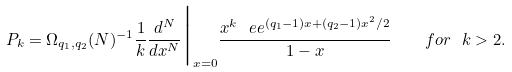<formula> <loc_0><loc_0><loc_500><loc_500>P _ { k } = \Omega _ { q _ { 1 } , q _ { 2 } } ( N ) ^ { - 1 } \frac { 1 } { k } \frac { d ^ { N } } { d x ^ { N } } \Big | _ { x = 0 } \frac { x ^ { k } \ e e ^ { ( q _ { 1 } - 1 ) x + ( q _ { 2 } - 1 ) x ^ { 2 } / 2 } } { 1 - x } \quad f o r \ { k > 2 } .</formula> 